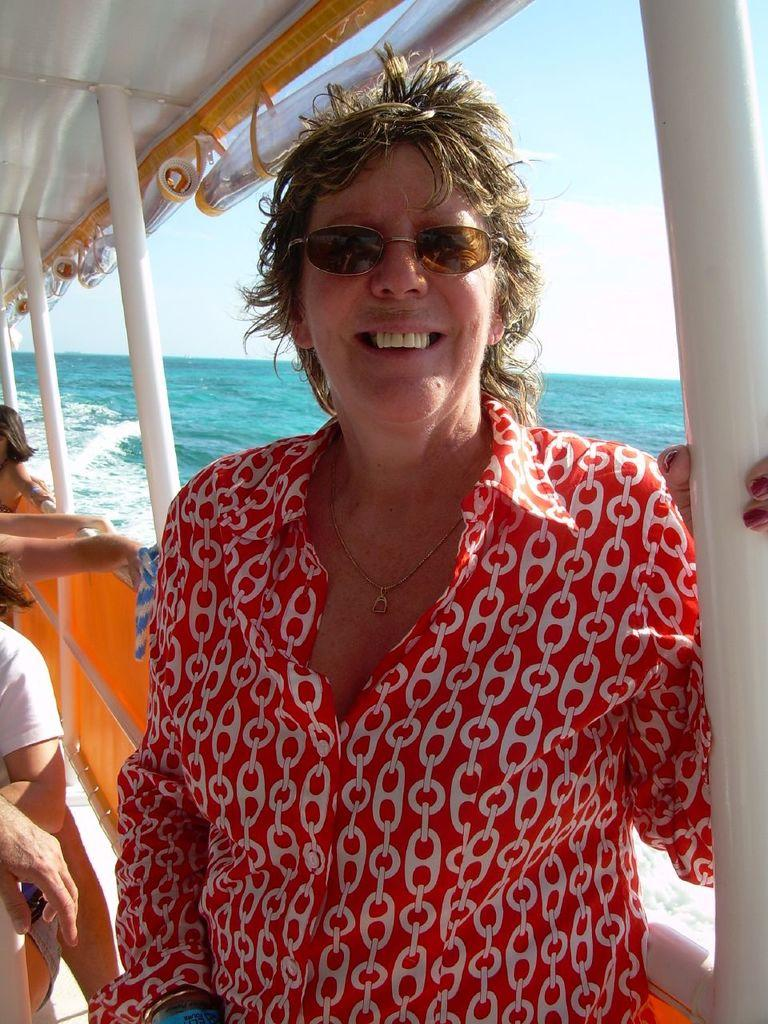Who is present in the image? There is a woman in the image. What are the people in the image doing? The people are in a boat in the image. What is the natural environment visible in the image? There is water visible in the image. What is visible at the top of the image? The sky is visible at the top of the image. What type of wine is being served by the farmer in the image? There is no farmer or wine present in the image. What role does the manager play in the image? There is no manager present in the image. 